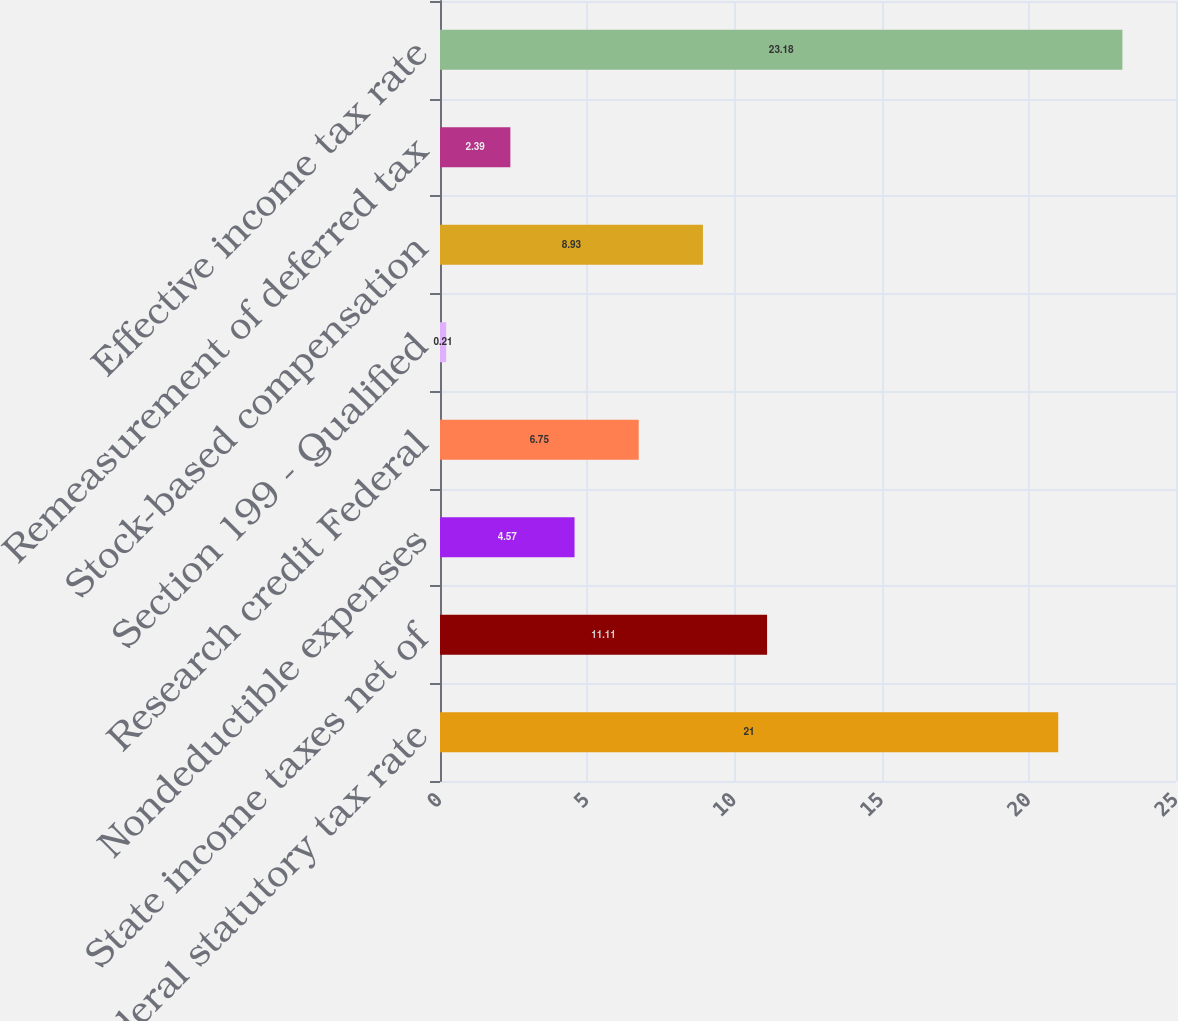Convert chart. <chart><loc_0><loc_0><loc_500><loc_500><bar_chart><fcel>Federal statutory tax rate<fcel>State income taxes net of<fcel>Nondeductible expenses<fcel>Research credit Federal<fcel>Section 199 - Qualified<fcel>Stock-based compensation<fcel>Remeasurement of deferred tax<fcel>Effective income tax rate<nl><fcel>21<fcel>11.11<fcel>4.57<fcel>6.75<fcel>0.21<fcel>8.93<fcel>2.39<fcel>23.18<nl></chart> 